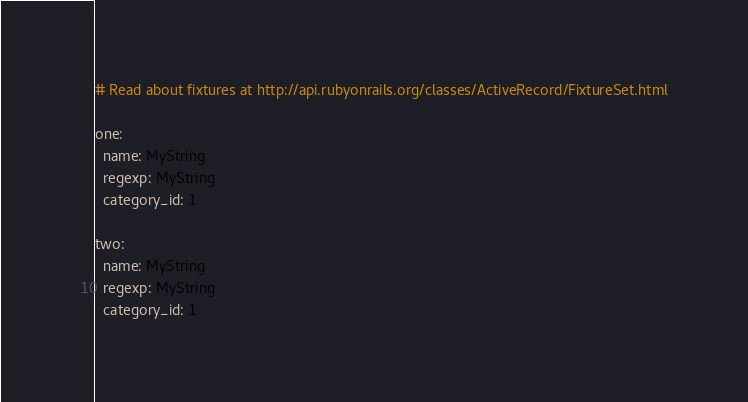<code> <loc_0><loc_0><loc_500><loc_500><_YAML_># Read about fixtures at http://api.rubyonrails.org/classes/ActiveRecord/FixtureSet.html

one:
  name: MyString
  regexp: MyString
  category_id: 1

two:
  name: MyString
  regexp: MyString
  category_id: 1
</code> 